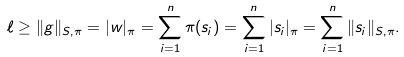<formula> <loc_0><loc_0><loc_500><loc_500>\ell \geq \| g \| _ { S , \pi } = | w | _ { \pi } = \sum _ { i = 1 } ^ { n } \pi ( s _ { i } ) = \sum _ { i = 1 } ^ { n } | s _ { i } | _ { \pi } = \sum _ { i = 1 } ^ { n } \| s _ { i } \| _ { S , \pi } .</formula> 